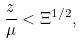Convert formula to latex. <formula><loc_0><loc_0><loc_500><loc_500>\frac { z } { \mu } < \Xi ^ { 1 / 2 } ,</formula> 